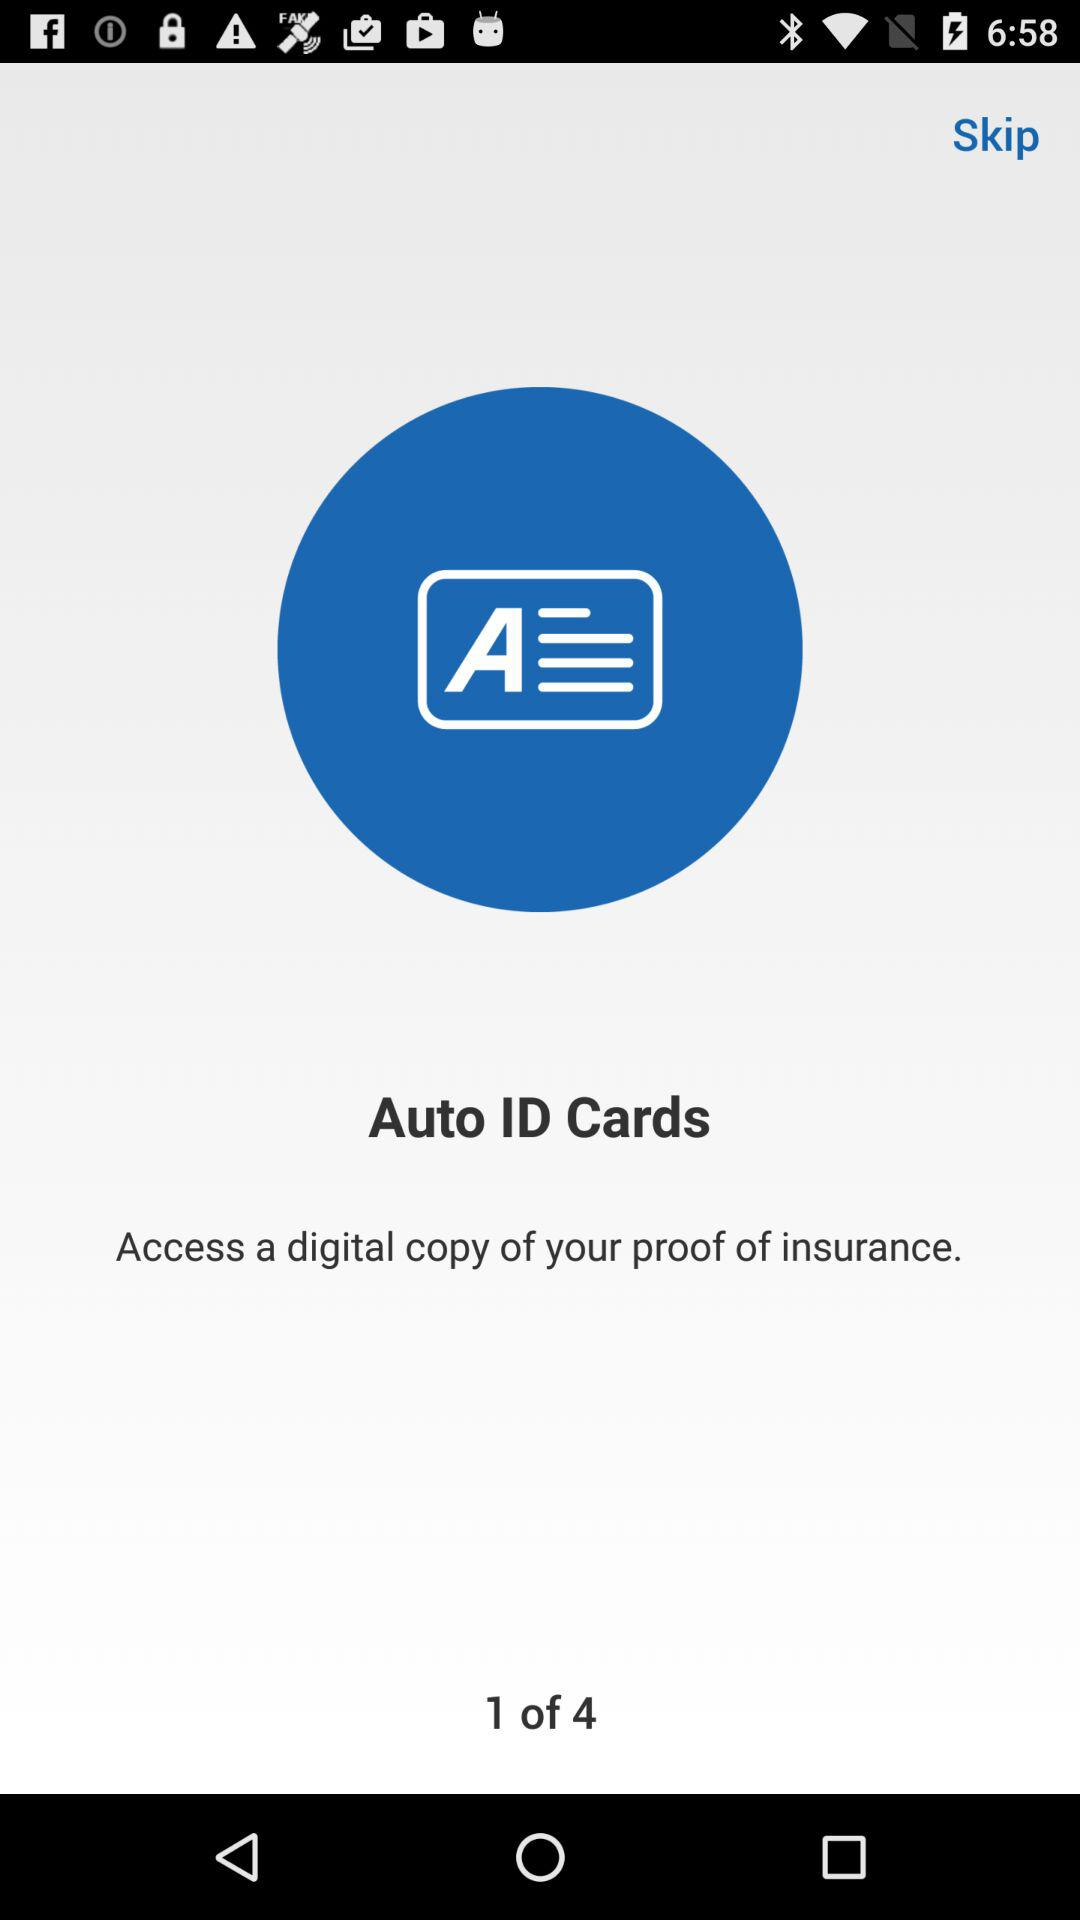How many pages in total are there? There are 4 pages. 